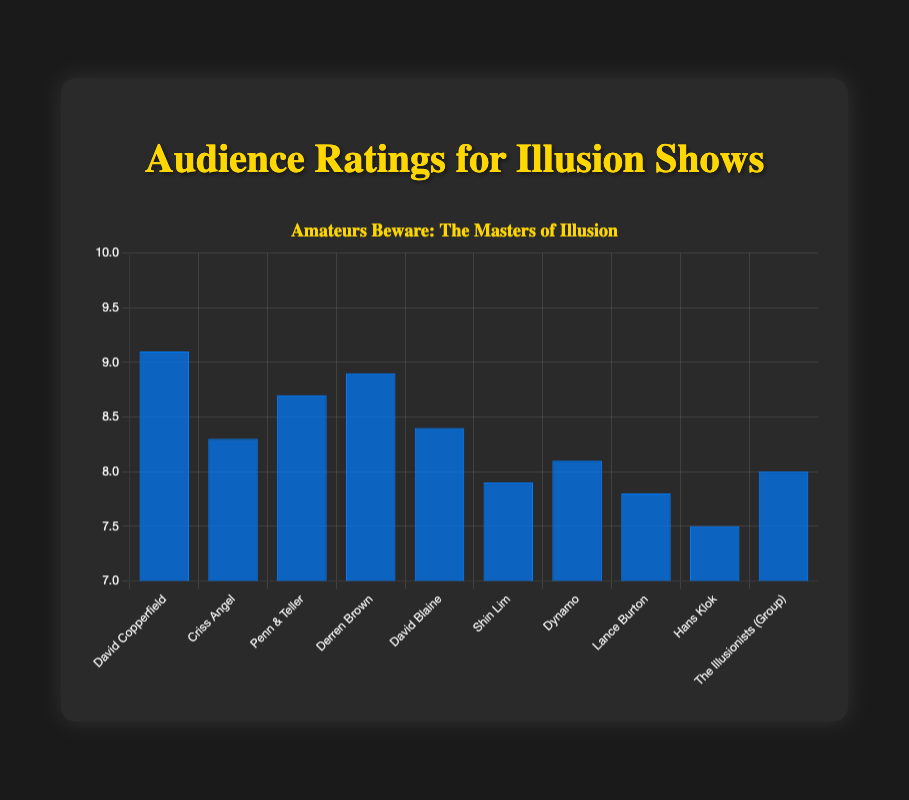What is the highest audience rating shown in the chart? The chart indicates that the highest audience rating is 9.1, which is associated with David Copperfield.
Answer: 9.1 Who has a higher audience rating, Criss Angel or Dynamo? The chart shows Criss Angel with a rating of 8.3 and Dynamo with a rating of 8.1, so Criss Angel has a higher rating.
Answer: Criss Angel What is the average audience rating of the top three illusionists? The top three illusionists by rating are David Copperfield (9.1), Derren Brown (8.9), and Penn & Teller (8.7). The average rating is (9.1 + 8.9 + 8.7) / 3 = 8.9.
Answer: 8.9 Which illusionist has the lowest audience rating, and what is it? The chart shows Hans Klok with the lowest audience rating at 7.5.
Answer: Hans Klok, 7.5 How does the rating of David Blaine compare to the average rating of Criss Angel and Shin Lim? The ratings of Criss Angel and Shin Lim are 8.3 and 7.9 respectively, with an average of (8.3 + 7.9) / 2 = 8.1. David Blaine's rating is 8.4, which is higher than the average 8.1.
Answer: Higher Which illusionist group has a rating of 8.0, and how does it compare visually to Lance Burton's rating? The Illusionists (Group) has a rating of 8.0, represented by a blue bar visually taller than Lance Burton's bar, whose rating is 7.8.
Answer: The Illusionists (Group), taller What is the difference between the highest and the lowest audience ratings in the chart? The highest rating is 9.1 (David Copperfield) and the lowest is 7.5 (Hans Klok). The difference is 9.1 - 7.5 = 1.6.
Answer: 1.6 If the ratings were grouped into categories of 7-8, 8-9, and 9-10, how many illusionists fall in each category? According to the chart, the categories contain:
- 7-8: Shin Lim, Lance Burton, Hans Klok (3)
- 8-9: Criss Angel, Penn & Teller, Derren Brown, David Blaine, Dynamo, The Illusionists (Group) (6)
- 9-10: David Copperfield (1)
Answer: 3, 6, 1 Which illusionist is closest to the average rating of all the illusionists listed? The total sum of the ratings is (9.1 + 8.3 + 8.7 + 8.9 + 8.4 + 7.9 + 8.1 + 7.8 + 7.5 + 8.0) = 82.7, and the average is 82.7 / 10 = 8.27. Criss Angel's rating of 8.3 is closest to this average.
Answer: Criss Angel 